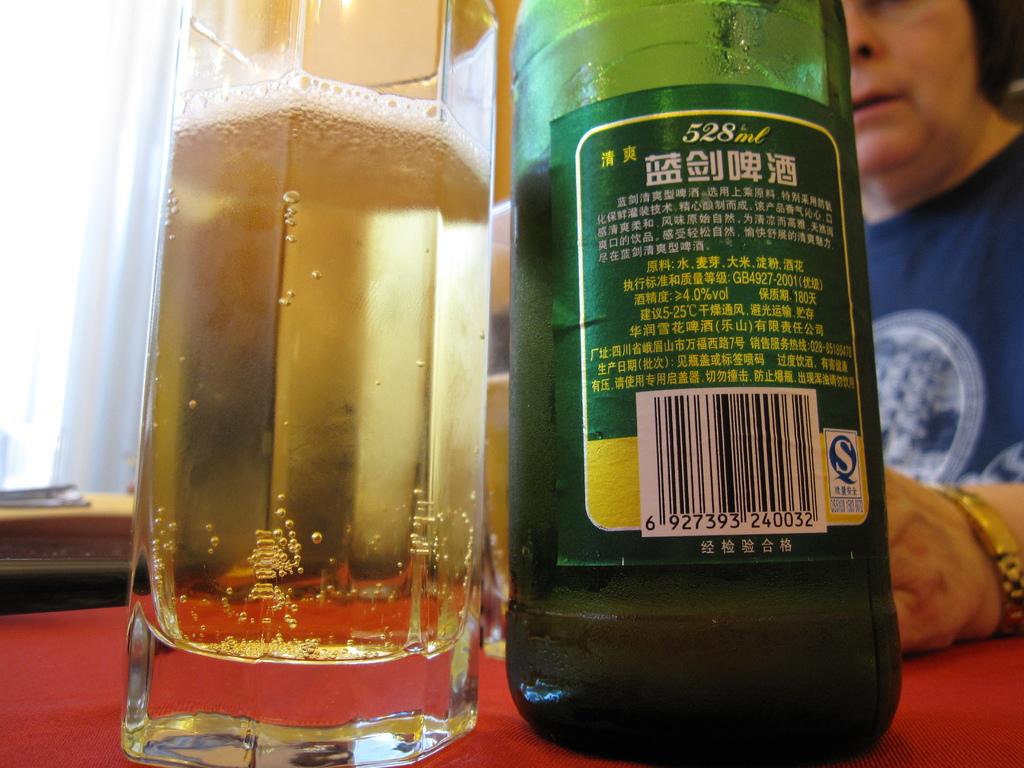How much volume is in the bottle?
Keep it short and to the point. 528ml. 